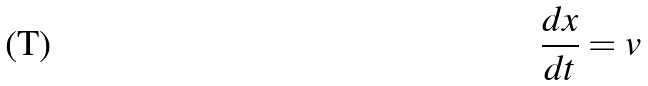<formula> <loc_0><loc_0><loc_500><loc_500>\frac { d x } { d t } = v</formula> 